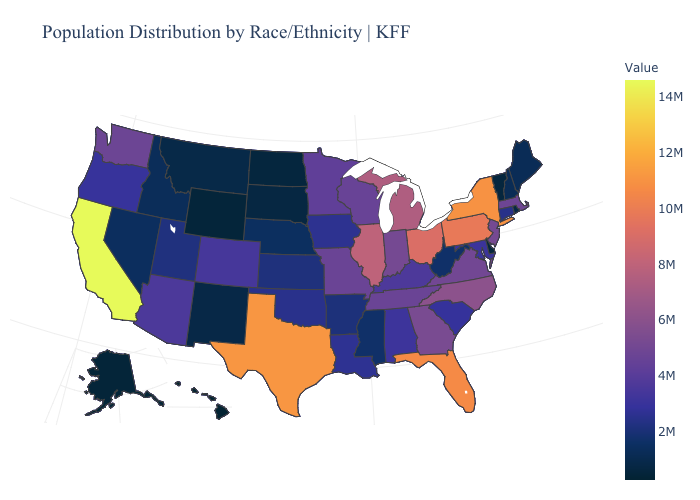Is the legend a continuous bar?
Answer briefly. Yes. Among the states that border Wisconsin , does Illinois have the highest value?
Write a very short answer. Yes. Does Vermont have a higher value than North Carolina?
Concise answer only. No. Among the states that border South Dakota , which have the lowest value?
Keep it brief. Wyoming. Does the map have missing data?
Write a very short answer. No. Among the states that border Michigan , which have the lowest value?
Give a very brief answer. Wisconsin. Which states have the highest value in the USA?
Keep it brief. California. Does New Mexico have the highest value in the West?
Be succinct. No. 